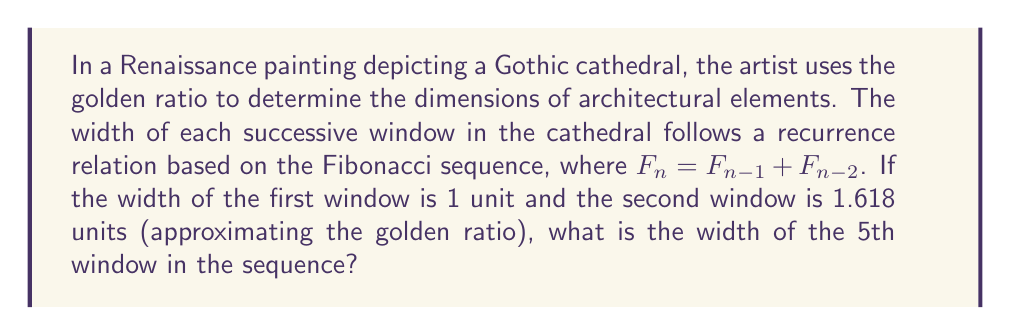Provide a solution to this math problem. Let's approach this step-by-step:

1) The given recurrence relation is based on the Fibonacci sequence: $F_n = F_{n-1} + F_{n-2}$

2) We're given that the first two terms are:
   $F_1 = 1$
   $F_2 = 1.618$

3) Let's calculate the subsequent terms:

   $F_3 = F_2 + F_1 = 1.618 + 1 = 2.618$

   $F_4 = F_3 + F_2 = 2.618 + 1.618 = 4.236$

   $F_5 = F_4 + F_3 = 4.236 + 2.618 = 6.854$

4) The 5th window corresponds to $F_5$, which we calculated to be 6.854 units wide.

5) Interestingly, this sequence approximates the golden ratio multiplication. Each term is approximately 1.618 times the previous term, which is the golden ratio (φ).

   $\frac{F_2}{F_1} \approx 1.618$
   $\frac{F_3}{F_2} \approx 1.618$
   $\frac{F_4}{F_3} \approx 1.618$
   $\frac{F_5}{F_4} \approx 1.618$

This demonstrates how the golden ratio, deeply embedded in Gothic architecture, was also utilized in Renaissance art, showing the continuity and evolution of aesthetic principles across these periods.
Answer: 6.854 units 